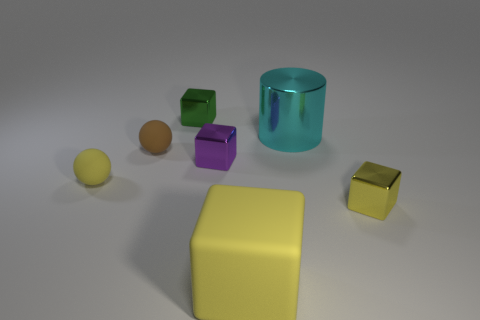Subtract 1 blocks. How many blocks are left? 3 Add 2 metallic cylinders. How many objects exist? 9 Subtract all cubes. How many objects are left? 3 Add 1 big matte blocks. How many big matte blocks are left? 2 Add 1 tiny green shiny things. How many tiny green shiny things exist? 2 Subtract 2 yellow cubes. How many objects are left? 5 Subtract all green things. Subtract all big cylinders. How many objects are left? 5 